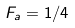Convert formula to latex. <formula><loc_0><loc_0><loc_500><loc_500>F _ { a } = 1 / 4</formula> 